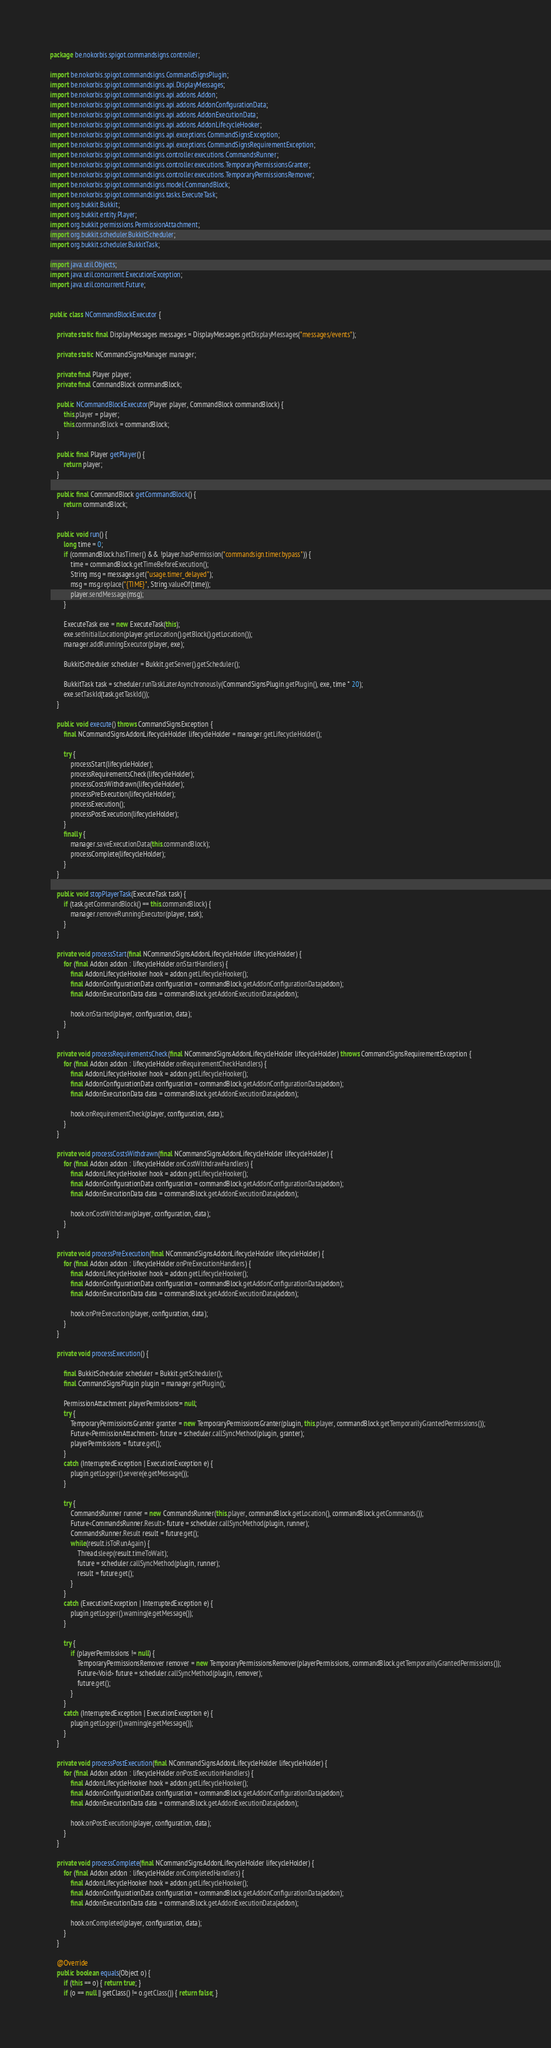Convert code to text. <code><loc_0><loc_0><loc_500><loc_500><_Java_>package be.nokorbis.spigot.commandsigns.controller;

import be.nokorbis.spigot.commandsigns.CommandSignsPlugin;
import be.nokorbis.spigot.commandsigns.api.DisplayMessages;
import be.nokorbis.spigot.commandsigns.api.addons.Addon;
import be.nokorbis.spigot.commandsigns.api.addons.AddonConfigurationData;
import be.nokorbis.spigot.commandsigns.api.addons.AddonExecutionData;
import be.nokorbis.spigot.commandsigns.api.addons.AddonLifecycleHooker;
import be.nokorbis.spigot.commandsigns.api.exceptions.CommandSignsException;
import be.nokorbis.spigot.commandsigns.api.exceptions.CommandSignsRequirementException;
import be.nokorbis.spigot.commandsigns.controller.executions.CommandsRunner;
import be.nokorbis.spigot.commandsigns.controller.executions.TemporaryPermissionsGranter;
import be.nokorbis.spigot.commandsigns.controller.executions.TemporaryPermissionsRemover;
import be.nokorbis.spigot.commandsigns.model.CommandBlock;
import be.nokorbis.spigot.commandsigns.tasks.ExecuteTask;
import org.bukkit.Bukkit;
import org.bukkit.entity.Player;
import org.bukkit.permissions.PermissionAttachment;
import org.bukkit.scheduler.BukkitScheduler;
import org.bukkit.scheduler.BukkitTask;

import java.util.Objects;
import java.util.concurrent.ExecutionException;
import java.util.concurrent.Future;


public class NCommandBlockExecutor {

	private static final DisplayMessages messages = DisplayMessages.getDisplayMessages("messages/events");

	private static NCommandSignsManager manager;

	private final Player player;
	private final CommandBlock commandBlock;

	public NCommandBlockExecutor(Player player, CommandBlock commandBlock) {
		this.player = player;
		this.commandBlock = commandBlock;
	}

	public final Player getPlayer() {
		return player;
	}

	public final CommandBlock getCommandBlock() {
		return commandBlock;
	}

	public void run() {
		long time = 0;
		if (commandBlock.hasTimer() && !player.hasPermission("commandsign.timer.bypass")) {
			time = commandBlock.getTimeBeforeExecution();
			String msg = messages.get("usage.timer_delayed");
			msg = msg.replace("{TIME}", String.valueOf(time));
			player.sendMessage(msg);
		}

		ExecuteTask exe = new ExecuteTask(this);
		exe.setInitialLocation(player.getLocation().getBlock().getLocation());
		manager.addRunningExecutor(player, exe);

		BukkitScheduler scheduler = Bukkit.getServer().getScheduler();

		BukkitTask task = scheduler.runTaskLaterAsynchronously(CommandSignsPlugin.getPlugin(), exe, time * 20);
		exe.setTaskId(task.getTaskId());
	}

	public void execute() throws CommandSignsException {
		final NCommandSignsAddonLifecycleHolder lifecycleHolder = manager.getLifecycleHolder();

		try {
			processStart(lifecycleHolder);
			processRequirementsCheck(lifecycleHolder);
			processCostsWithdrawn(lifecycleHolder);
			processPreExecution(lifecycleHolder);
			processExecution();
			processPostExecution(lifecycleHolder);
		}
		finally {
			manager.saveExecutionData(this.commandBlock);
			processComplete(lifecycleHolder);
		}
	}

	public void stopPlayerTask(ExecuteTask task) {
		if (task.getCommandBlock() == this.commandBlock) {
			manager.removeRunningExecutor(player, task);
		}
	}

	private void processStart(final NCommandSignsAddonLifecycleHolder lifecycleHolder) {
		for (final Addon addon : lifecycleHolder.onStartHandlers) {
			final AddonLifecycleHooker hook = addon.getLifecycleHooker();
			final AddonConfigurationData configuration = commandBlock.getAddonConfigurationData(addon);
			final AddonExecutionData data = commandBlock.getAddonExecutionData(addon);

			hook.onStarted(player, configuration, data);
		}
	}

	private void processRequirementsCheck(final NCommandSignsAddonLifecycleHolder lifecycleHolder) throws CommandSignsRequirementException {
		for (final Addon addon : lifecycleHolder.onRequirementCheckHandlers) {
			final AddonLifecycleHooker hook = addon.getLifecycleHooker();
			final AddonConfigurationData configuration = commandBlock.getAddonConfigurationData(addon);
			final AddonExecutionData data = commandBlock.getAddonExecutionData(addon);

			hook.onRequirementCheck(player, configuration, data);
		}
	}

	private void processCostsWithdrawn(final NCommandSignsAddonLifecycleHolder lifecycleHolder) {
		for (final Addon addon : lifecycleHolder.onCostWithdrawHandlers) {
			final AddonLifecycleHooker hook = addon.getLifecycleHooker();
			final AddonConfigurationData configuration = commandBlock.getAddonConfigurationData(addon);
			final AddonExecutionData data = commandBlock.getAddonExecutionData(addon);

			hook.onCostWithdraw(player, configuration, data);
		}
	}

	private void processPreExecution(final NCommandSignsAddonLifecycleHolder lifecycleHolder) {
		for (final Addon addon : lifecycleHolder.onPreExecutionHandlers) {
			final AddonLifecycleHooker hook = addon.getLifecycleHooker();
			final AddonConfigurationData configuration = commandBlock.getAddonConfigurationData(addon);
			final AddonExecutionData data = commandBlock.getAddonExecutionData(addon);

			hook.onPreExecution(player, configuration, data);
		}
	}

	private void processExecution() {

		final BukkitScheduler scheduler = Bukkit.getScheduler();
		final CommandSignsPlugin plugin = manager.getPlugin();

		PermissionAttachment playerPermissions= null;
		try {
			TemporaryPermissionsGranter granter = new TemporaryPermissionsGranter(plugin, this.player, commandBlock.getTemporarilyGrantedPermissions());
			Future<PermissionAttachment> future = scheduler.callSyncMethod(plugin, granter);
			playerPermissions = future.get();
		}
		catch (InterruptedException | ExecutionException e) {
			plugin.getLogger().severe(e.getMessage());
		}

		try {
			CommandsRunner runner = new CommandsRunner(this.player, commandBlock.getLocation(), commandBlock.getCommands());
			Future<CommandsRunner.Result> future = scheduler.callSyncMethod(plugin, runner);
			CommandsRunner.Result result = future.get();
			while(result.isToRunAgain) {
				Thread.sleep(result.timeToWait);
				future = scheduler.callSyncMethod(plugin, runner);
				result = future.get();
			}
		}
		catch (ExecutionException | InterruptedException e) {
			plugin.getLogger().warning(e.getMessage());
		}

		try {
			if (playerPermissions != null) {
				TemporaryPermissionsRemover remover = new TemporaryPermissionsRemover(playerPermissions, commandBlock.getTemporarilyGrantedPermissions());
				Future<Void> future = scheduler.callSyncMethod(plugin, remover);
				future.get();
			}
		}
		catch (InterruptedException | ExecutionException e) {
			plugin.getLogger().warning(e.getMessage());
		}
	}

	private void processPostExecution(final NCommandSignsAddonLifecycleHolder lifecycleHolder) {
		for (final Addon addon : lifecycleHolder.onPostExecutionHandlers) {
			final AddonLifecycleHooker hook = addon.getLifecycleHooker();
			final AddonConfigurationData configuration = commandBlock.getAddonConfigurationData(addon);
			final AddonExecutionData data = commandBlock.getAddonExecutionData(addon);

			hook.onPostExecution(player, configuration, data);
		}
	}

	private void processComplete(final NCommandSignsAddonLifecycleHolder lifecycleHolder) {
		for (final Addon addon : lifecycleHolder.onCompletedHandlers) {
			final AddonLifecycleHooker hook = addon.getLifecycleHooker();
			final AddonConfigurationData configuration = commandBlock.getAddonConfigurationData(addon);
			final AddonExecutionData data = commandBlock.getAddonExecutionData(addon);

			hook.onCompleted(player, configuration, data);
		}
	}

	@Override
	public boolean equals(Object o) {
		if (this == o) { return true; }
		if (o == null || getClass() != o.getClass()) { return false; }</code> 